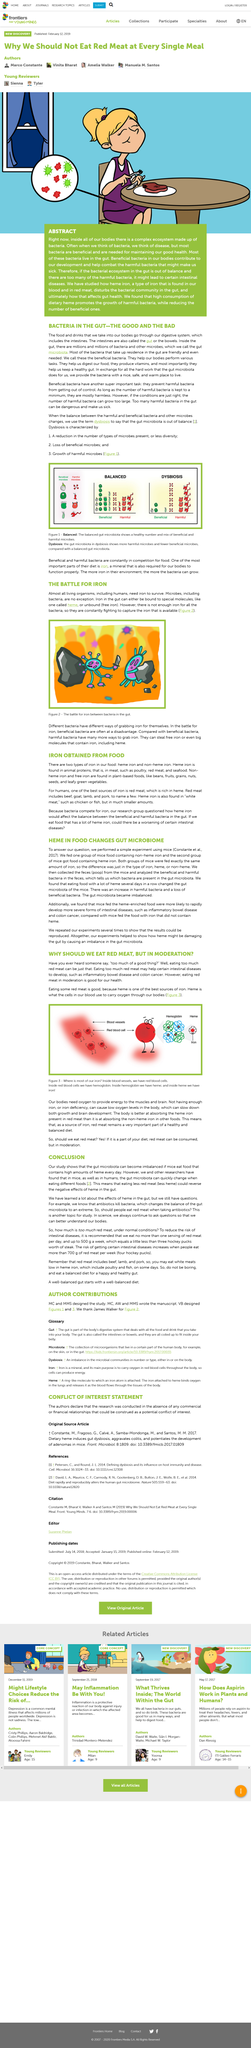List a handful of essential elements in this visual. The experiment conducted on mice demonstrated how heme, a byproduct of cooking meat, could harm the gut by disrupting the balance of the gut microbiome. Most microbes require iron to live and thrive, making it an essential micronutrient for the vast majority of microorganisms. The intestines are an integral part of the digestive system. Our bodies require oxygen in order to provide energy to our muscles and brain. Harmful bacteria have the ability to steal iron, an essential element for the proper functioning of the body. This can lead to the development of iron deficiency anemia, a condition characterized by a low level of iron in the blood. 